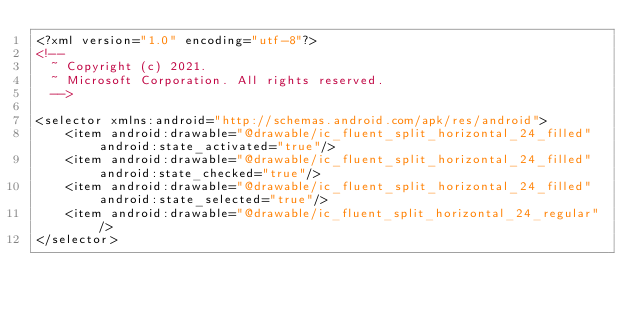Convert code to text. <code><loc_0><loc_0><loc_500><loc_500><_XML_><?xml version="1.0" encoding="utf-8"?>
<!--
  ~ Copyright (c) 2021.
  ~ Microsoft Corporation. All rights reserved.
  -->

<selector xmlns:android="http://schemas.android.com/apk/res/android">
    <item android:drawable="@drawable/ic_fluent_split_horizontal_24_filled" android:state_activated="true"/>
    <item android:drawable="@drawable/ic_fluent_split_horizontal_24_filled" android:state_checked="true"/>
    <item android:drawable="@drawable/ic_fluent_split_horizontal_24_filled" android:state_selected="true"/>
    <item android:drawable="@drawable/ic_fluent_split_horizontal_24_regular"/>
</selector>
</code> 